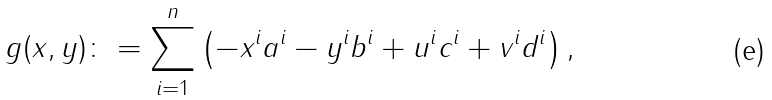Convert formula to latex. <formula><loc_0><loc_0><loc_500><loc_500>g ( x , y ) \colon = \sum _ { i = 1 } ^ { n } \left ( - x ^ { i } a ^ { i } - y ^ { i } b ^ { i } + u ^ { i } c ^ { i } + v ^ { i } d ^ { i } \right ) ,</formula> 